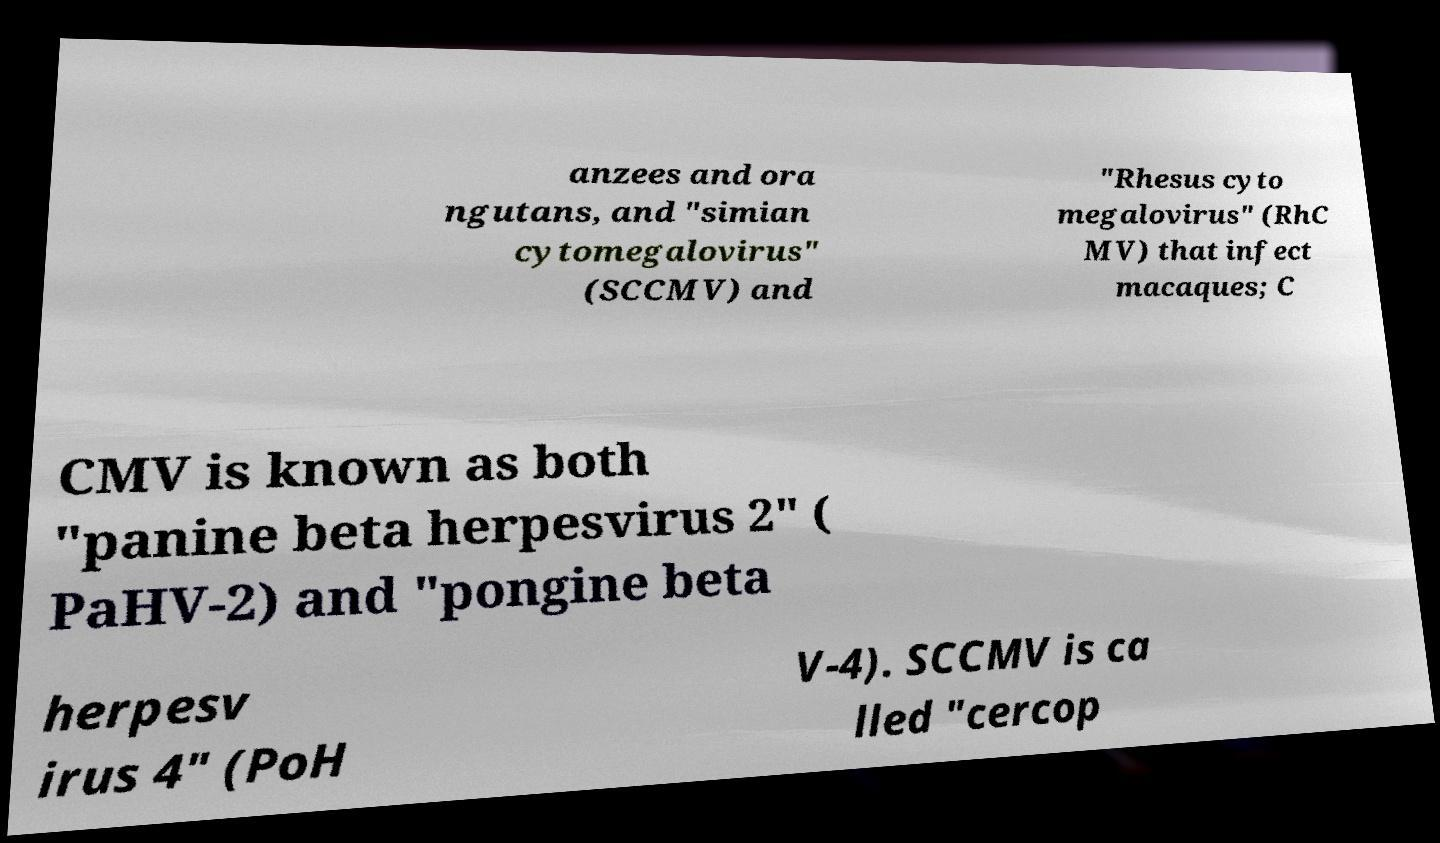I need the written content from this picture converted into text. Can you do that? anzees and ora ngutans, and "simian cytomegalovirus" (SCCMV) and "Rhesus cyto megalovirus" (RhC MV) that infect macaques; C CMV is known as both "panine beta herpesvirus 2" ( PaHV-2) and "pongine beta herpesv irus 4" (PoH V-4). SCCMV is ca lled "cercop 